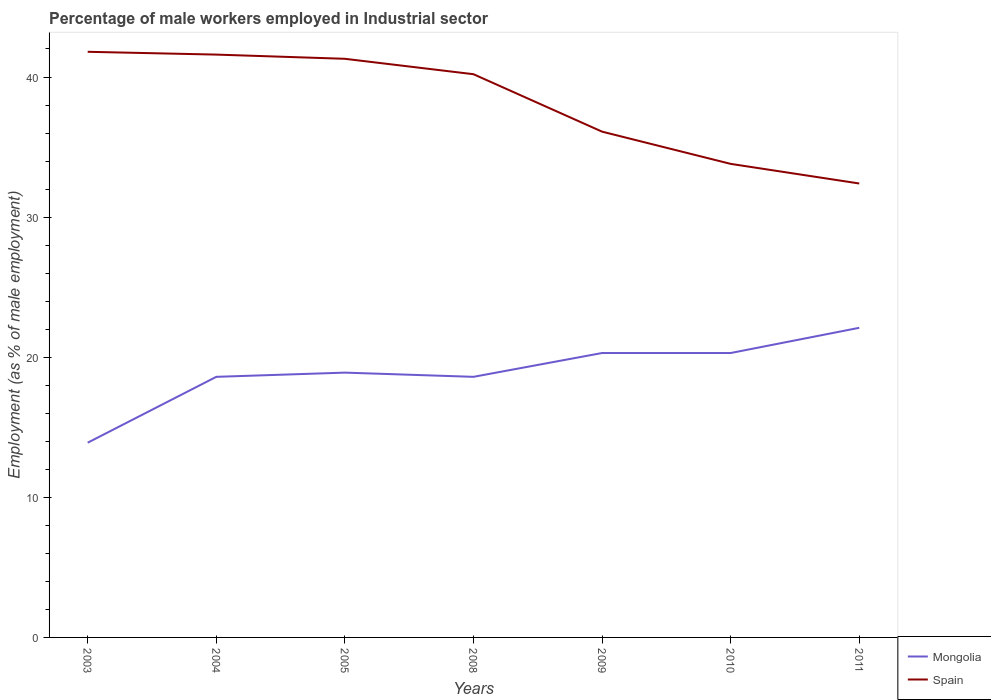How many different coloured lines are there?
Offer a very short reply. 2. Is the number of lines equal to the number of legend labels?
Provide a succinct answer. Yes. Across all years, what is the maximum percentage of male workers employed in Industrial sector in Spain?
Keep it short and to the point. 32.4. What is the total percentage of male workers employed in Industrial sector in Mongolia in the graph?
Offer a very short reply. -1.7. What is the difference between the highest and the second highest percentage of male workers employed in Industrial sector in Mongolia?
Give a very brief answer. 8.2. What is the difference between the highest and the lowest percentage of male workers employed in Industrial sector in Mongolia?
Offer a terse response. 3. Is the percentage of male workers employed in Industrial sector in Mongolia strictly greater than the percentage of male workers employed in Industrial sector in Spain over the years?
Ensure brevity in your answer.  Yes. How many lines are there?
Provide a short and direct response. 2. How many years are there in the graph?
Offer a terse response. 7. What is the difference between two consecutive major ticks on the Y-axis?
Provide a short and direct response. 10. Does the graph contain any zero values?
Your response must be concise. No. Does the graph contain grids?
Provide a succinct answer. No. Where does the legend appear in the graph?
Provide a short and direct response. Bottom right. How many legend labels are there?
Make the answer very short. 2. How are the legend labels stacked?
Provide a succinct answer. Vertical. What is the title of the graph?
Provide a succinct answer. Percentage of male workers employed in Industrial sector. Does "Angola" appear as one of the legend labels in the graph?
Your answer should be compact. No. What is the label or title of the Y-axis?
Your answer should be very brief. Employment (as % of male employment). What is the Employment (as % of male employment) of Mongolia in 2003?
Make the answer very short. 13.9. What is the Employment (as % of male employment) of Spain in 2003?
Provide a succinct answer. 41.8. What is the Employment (as % of male employment) of Mongolia in 2004?
Keep it short and to the point. 18.6. What is the Employment (as % of male employment) of Spain in 2004?
Offer a terse response. 41.6. What is the Employment (as % of male employment) in Mongolia in 2005?
Keep it short and to the point. 18.9. What is the Employment (as % of male employment) in Spain in 2005?
Your answer should be very brief. 41.3. What is the Employment (as % of male employment) of Mongolia in 2008?
Your response must be concise. 18.6. What is the Employment (as % of male employment) of Spain in 2008?
Make the answer very short. 40.2. What is the Employment (as % of male employment) of Mongolia in 2009?
Give a very brief answer. 20.3. What is the Employment (as % of male employment) in Spain in 2009?
Ensure brevity in your answer.  36.1. What is the Employment (as % of male employment) of Mongolia in 2010?
Keep it short and to the point. 20.3. What is the Employment (as % of male employment) in Spain in 2010?
Offer a very short reply. 33.8. What is the Employment (as % of male employment) of Mongolia in 2011?
Give a very brief answer. 22.1. What is the Employment (as % of male employment) of Spain in 2011?
Keep it short and to the point. 32.4. Across all years, what is the maximum Employment (as % of male employment) in Mongolia?
Your response must be concise. 22.1. Across all years, what is the maximum Employment (as % of male employment) of Spain?
Your response must be concise. 41.8. Across all years, what is the minimum Employment (as % of male employment) in Mongolia?
Your response must be concise. 13.9. Across all years, what is the minimum Employment (as % of male employment) of Spain?
Ensure brevity in your answer.  32.4. What is the total Employment (as % of male employment) in Mongolia in the graph?
Ensure brevity in your answer.  132.7. What is the total Employment (as % of male employment) in Spain in the graph?
Give a very brief answer. 267.2. What is the difference between the Employment (as % of male employment) of Mongolia in 2003 and that in 2004?
Make the answer very short. -4.7. What is the difference between the Employment (as % of male employment) in Spain in 2003 and that in 2004?
Provide a short and direct response. 0.2. What is the difference between the Employment (as % of male employment) in Mongolia in 2003 and that in 2005?
Give a very brief answer. -5. What is the difference between the Employment (as % of male employment) in Spain in 2003 and that in 2010?
Your answer should be very brief. 8. What is the difference between the Employment (as % of male employment) of Mongolia in 2003 and that in 2011?
Offer a terse response. -8.2. What is the difference between the Employment (as % of male employment) in Mongolia in 2004 and that in 2005?
Provide a succinct answer. -0.3. What is the difference between the Employment (as % of male employment) of Spain in 2004 and that in 2005?
Provide a short and direct response. 0.3. What is the difference between the Employment (as % of male employment) of Spain in 2004 and that in 2008?
Provide a short and direct response. 1.4. What is the difference between the Employment (as % of male employment) in Mongolia in 2004 and that in 2009?
Your answer should be very brief. -1.7. What is the difference between the Employment (as % of male employment) in Mongolia in 2004 and that in 2010?
Provide a short and direct response. -1.7. What is the difference between the Employment (as % of male employment) in Spain in 2004 and that in 2010?
Offer a terse response. 7.8. What is the difference between the Employment (as % of male employment) of Mongolia in 2004 and that in 2011?
Your answer should be very brief. -3.5. What is the difference between the Employment (as % of male employment) in Mongolia in 2005 and that in 2009?
Keep it short and to the point. -1.4. What is the difference between the Employment (as % of male employment) in Mongolia in 2005 and that in 2010?
Keep it short and to the point. -1.4. What is the difference between the Employment (as % of male employment) in Spain in 2005 and that in 2010?
Your answer should be compact. 7.5. What is the difference between the Employment (as % of male employment) in Mongolia in 2008 and that in 2009?
Offer a terse response. -1.7. What is the difference between the Employment (as % of male employment) of Spain in 2008 and that in 2009?
Your response must be concise. 4.1. What is the difference between the Employment (as % of male employment) in Mongolia in 2008 and that in 2010?
Provide a short and direct response. -1.7. What is the difference between the Employment (as % of male employment) in Spain in 2008 and that in 2010?
Provide a short and direct response. 6.4. What is the difference between the Employment (as % of male employment) in Spain in 2009 and that in 2010?
Your response must be concise. 2.3. What is the difference between the Employment (as % of male employment) of Spain in 2010 and that in 2011?
Your answer should be very brief. 1.4. What is the difference between the Employment (as % of male employment) in Mongolia in 2003 and the Employment (as % of male employment) in Spain in 2004?
Provide a short and direct response. -27.7. What is the difference between the Employment (as % of male employment) in Mongolia in 2003 and the Employment (as % of male employment) in Spain in 2005?
Offer a terse response. -27.4. What is the difference between the Employment (as % of male employment) in Mongolia in 2003 and the Employment (as % of male employment) in Spain in 2008?
Your answer should be very brief. -26.3. What is the difference between the Employment (as % of male employment) of Mongolia in 2003 and the Employment (as % of male employment) of Spain in 2009?
Offer a terse response. -22.2. What is the difference between the Employment (as % of male employment) of Mongolia in 2003 and the Employment (as % of male employment) of Spain in 2010?
Offer a terse response. -19.9. What is the difference between the Employment (as % of male employment) in Mongolia in 2003 and the Employment (as % of male employment) in Spain in 2011?
Your response must be concise. -18.5. What is the difference between the Employment (as % of male employment) of Mongolia in 2004 and the Employment (as % of male employment) of Spain in 2005?
Your response must be concise. -22.7. What is the difference between the Employment (as % of male employment) of Mongolia in 2004 and the Employment (as % of male employment) of Spain in 2008?
Provide a short and direct response. -21.6. What is the difference between the Employment (as % of male employment) of Mongolia in 2004 and the Employment (as % of male employment) of Spain in 2009?
Offer a terse response. -17.5. What is the difference between the Employment (as % of male employment) of Mongolia in 2004 and the Employment (as % of male employment) of Spain in 2010?
Provide a succinct answer. -15.2. What is the difference between the Employment (as % of male employment) of Mongolia in 2005 and the Employment (as % of male employment) of Spain in 2008?
Keep it short and to the point. -21.3. What is the difference between the Employment (as % of male employment) of Mongolia in 2005 and the Employment (as % of male employment) of Spain in 2009?
Keep it short and to the point. -17.2. What is the difference between the Employment (as % of male employment) in Mongolia in 2005 and the Employment (as % of male employment) in Spain in 2010?
Ensure brevity in your answer.  -14.9. What is the difference between the Employment (as % of male employment) of Mongolia in 2008 and the Employment (as % of male employment) of Spain in 2009?
Your answer should be compact. -17.5. What is the difference between the Employment (as % of male employment) of Mongolia in 2008 and the Employment (as % of male employment) of Spain in 2010?
Your answer should be very brief. -15.2. What is the difference between the Employment (as % of male employment) in Mongolia in 2009 and the Employment (as % of male employment) in Spain in 2010?
Provide a short and direct response. -13.5. What is the difference between the Employment (as % of male employment) in Mongolia in 2009 and the Employment (as % of male employment) in Spain in 2011?
Make the answer very short. -12.1. What is the difference between the Employment (as % of male employment) in Mongolia in 2010 and the Employment (as % of male employment) in Spain in 2011?
Keep it short and to the point. -12.1. What is the average Employment (as % of male employment) in Mongolia per year?
Your response must be concise. 18.96. What is the average Employment (as % of male employment) in Spain per year?
Your response must be concise. 38.17. In the year 2003, what is the difference between the Employment (as % of male employment) of Mongolia and Employment (as % of male employment) of Spain?
Your answer should be compact. -27.9. In the year 2005, what is the difference between the Employment (as % of male employment) in Mongolia and Employment (as % of male employment) in Spain?
Your answer should be very brief. -22.4. In the year 2008, what is the difference between the Employment (as % of male employment) of Mongolia and Employment (as % of male employment) of Spain?
Your answer should be compact. -21.6. In the year 2009, what is the difference between the Employment (as % of male employment) of Mongolia and Employment (as % of male employment) of Spain?
Offer a terse response. -15.8. In the year 2010, what is the difference between the Employment (as % of male employment) of Mongolia and Employment (as % of male employment) of Spain?
Keep it short and to the point. -13.5. What is the ratio of the Employment (as % of male employment) in Mongolia in 2003 to that in 2004?
Ensure brevity in your answer.  0.75. What is the ratio of the Employment (as % of male employment) in Mongolia in 2003 to that in 2005?
Your response must be concise. 0.74. What is the ratio of the Employment (as % of male employment) in Spain in 2003 to that in 2005?
Make the answer very short. 1.01. What is the ratio of the Employment (as % of male employment) of Mongolia in 2003 to that in 2008?
Keep it short and to the point. 0.75. What is the ratio of the Employment (as % of male employment) in Spain in 2003 to that in 2008?
Provide a succinct answer. 1.04. What is the ratio of the Employment (as % of male employment) of Mongolia in 2003 to that in 2009?
Offer a very short reply. 0.68. What is the ratio of the Employment (as % of male employment) in Spain in 2003 to that in 2009?
Your response must be concise. 1.16. What is the ratio of the Employment (as % of male employment) in Mongolia in 2003 to that in 2010?
Make the answer very short. 0.68. What is the ratio of the Employment (as % of male employment) of Spain in 2003 to that in 2010?
Give a very brief answer. 1.24. What is the ratio of the Employment (as % of male employment) in Mongolia in 2003 to that in 2011?
Provide a short and direct response. 0.63. What is the ratio of the Employment (as % of male employment) in Spain in 2003 to that in 2011?
Your response must be concise. 1.29. What is the ratio of the Employment (as % of male employment) of Mongolia in 2004 to that in 2005?
Offer a terse response. 0.98. What is the ratio of the Employment (as % of male employment) of Spain in 2004 to that in 2005?
Offer a very short reply. 1.01. What is the ratio of the Employment (as % of male employment) in Mongolia in 2004 to that in 2008?
Offer a terse response. 1. What is the ratio of the Employment (as % of male employment) of Spain in 2004 to that in 2008?
Your response must be concise. 1.03. What is the ratio of the Employment (as % of male employment) of Mongolia in 2004 to that in 2009?
Ensure brevity in your answer.  0.92. What is the ratio of the Employment (as % of male employment) of Spain in 2004 to that in 2009?
Your response must be concise. 1.15. What is the ratio of the Employment (as % of male employment) in Mongolia in 2004 to that in 2010?
Your answer should be very brief. 0.92. What is the ratio of the Employment (as % of male employment) of Spain in 2004 to that in 2010?
Provide a short and direct response. 1.23. What is the ratio of the Employment (as % of male employment) of Mongolia in 2004 to that in 2011?
Your answer should be compact. 0.84. What is the ratio of the Employment (as % of male employment) in Spain in 2004 to that in 2011?
Give a very brief answer. 1.28. What is the ratio of the Employment (as % of male employment) of Mongolia in 2005 to that in 2008?
Your answer should be very brief. 1.02. What is the ratio of the Employment (as % of male employment) in Spain in 2005 to that in 2008?
Your answer should be very brief. 1.03. What is the ratio of the Employment (as % of male employment) in Spain in 2005 to that in 2009?
Ensure brevity in your answer.  1.14. What is the ratio of the Employment (as % of male employment) of Mongolia in 2005 to that in 2010?
Ensure brevity in your answer.  0.93. What is the ratio of the Employment (as % of male employment) of Spain in 2005 to that in 2010?
Provide a succinct answer. 1.22. What is the ratio of the Employment (as % of male employment) in Mongolia in 2005 to that in 2011?
Keep it short and to the point. 0.86. What is the ratio of the Employment (as % of male employment) of Spain in 2005 to that in 2011?
Your answer should be very brief. 1.27. What is the ratio of the Employment (as % of male employment) of Mongolia in 2008 to that in 2009?
Make the answer very short. 0.92. What is the ratio of the Employment (as % of male employment) of Spain in 2008 to that in 2009?
Offer a terse response. 1.11. What is the ratio of the Employment (as % of male employment) in Mongolia in 2008 to that in 2010?
Offer a terse response. 0.92. What is the ratio of the Employment (as % of male employment) in Spain in 2008 to that in 2010?
Your response must be concise. 1.19. What is the ratio of the Employment (as % of male employment) of Mongolia in 2008 to that in 2011?
Provide a succinct answer. 0.84. What is the ratio of the Employment (as % of male employment) of Spain in 2008 to that in 2011?
Provide a short and direct response. 1.24. What is the ratio of the Employment (as % of male employment) in Mongolia in 2009 to that in 2010?
Your answer should be compact. 1. What is the ratio of the Employment (as % of male employment) in Spain in 2009 to that in 2010?
Ensure brevity in your answer.  1.07. What is the ratio of the Employment (as % of male employment) in Mongolia in 2009 to that in 2011?
Give a very brief answer. 0.92. What is the ratio of the Employment (as % of male employment) in Spain in 2009 to that in 2011?
Your answer should be compact. 1.11. What is the ratio of the Employment (as % of male employment) in Mongolia in 2010 to that in 2011?
Provide a succinct answer. 0.92. What is the ratio of the Employment (as % of male employment) in Spain in 2010 to that in 2011?
Give a very brief answer. 1.04. 